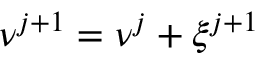<formula> <loc_0><loc_0><loc_500><loc_500>{ \boldsymbol \nu } ^ { j + 1 } = { \boldsymbol \nu } ^ { j } + \boldsymbol \xi ^ { j + 1 }</formula> 